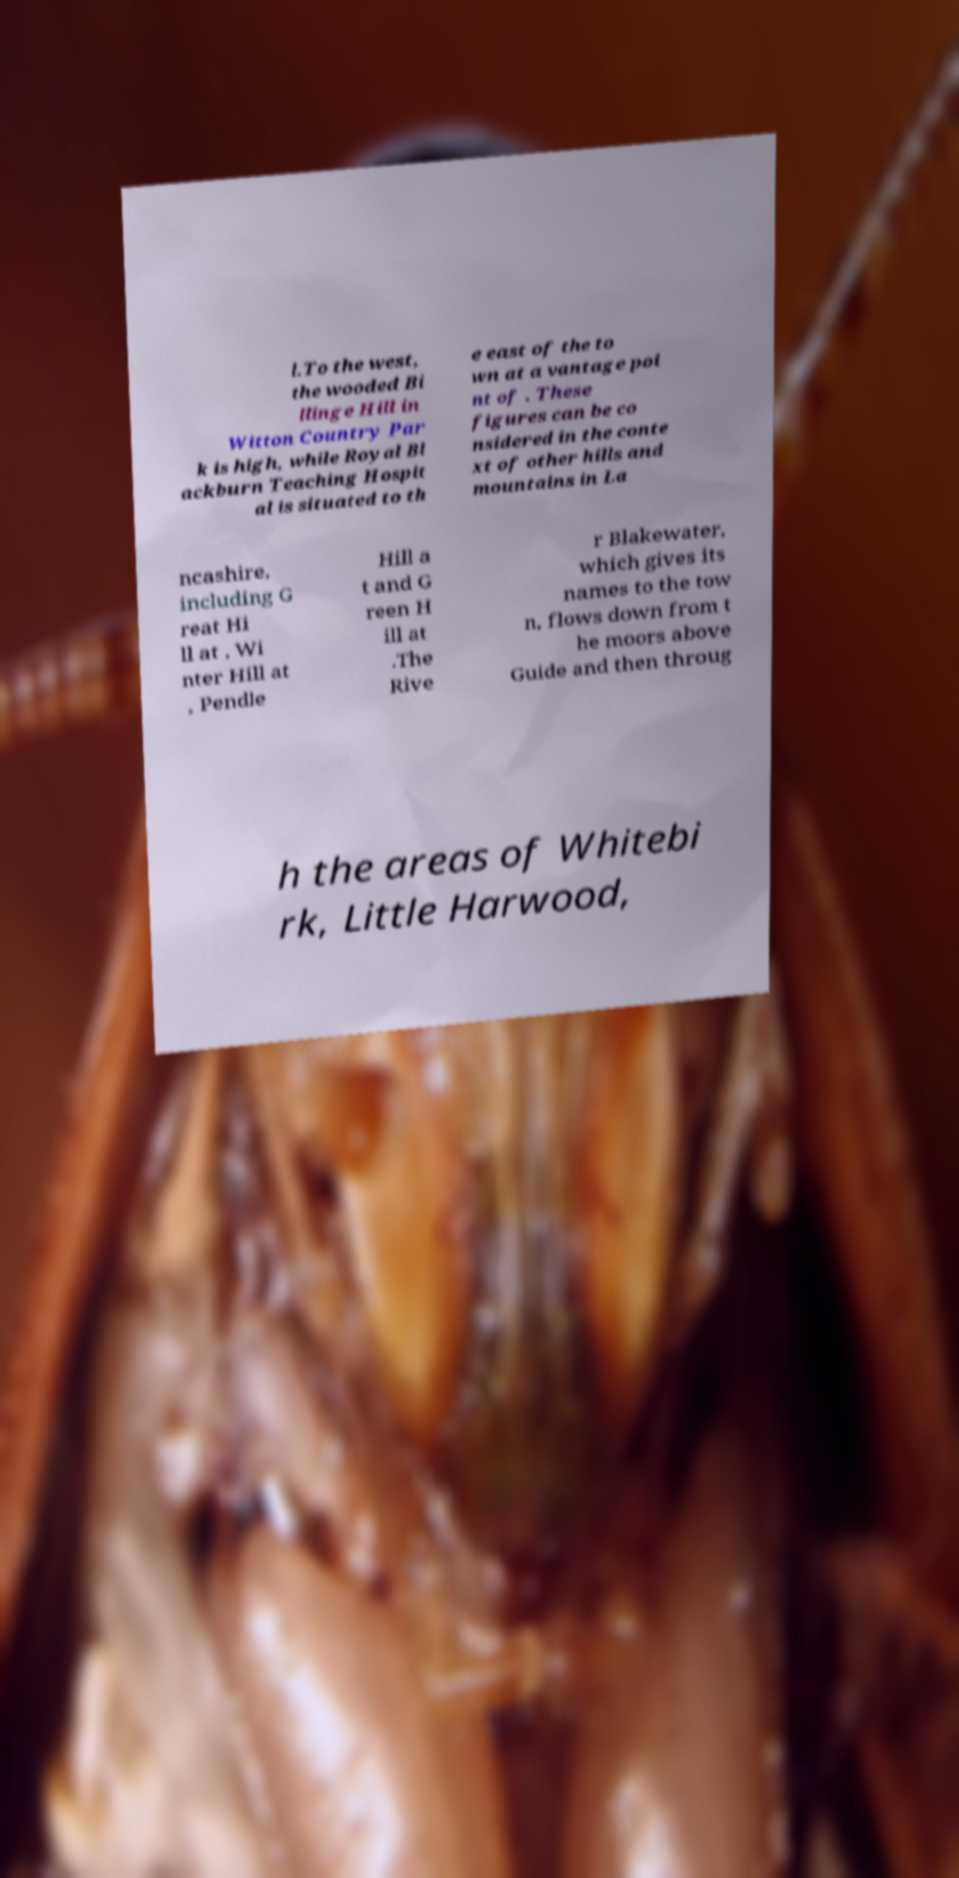There's text embedded in this image that I need extracted. Can you transcribe it verbatim? l.To the west, the wooded Bi llinge Hill in Witton Country Par k is high, while Royal Bl ackburn Teaching Hospit al is situated to th e east of the to wn at a vantage poi nt of . These figures can be co nsidered in the conte xt of other hills and mountains in La ncashire, including G reat Hi ll at , Wi nter Hill at , Pendle Hill a t and G reen H ill at .The Rive r Blakewater, which gives its names to the tow n, flows down from t he moors above Guide and then throug h the areas of Whitebi rk, Little Harwood, 